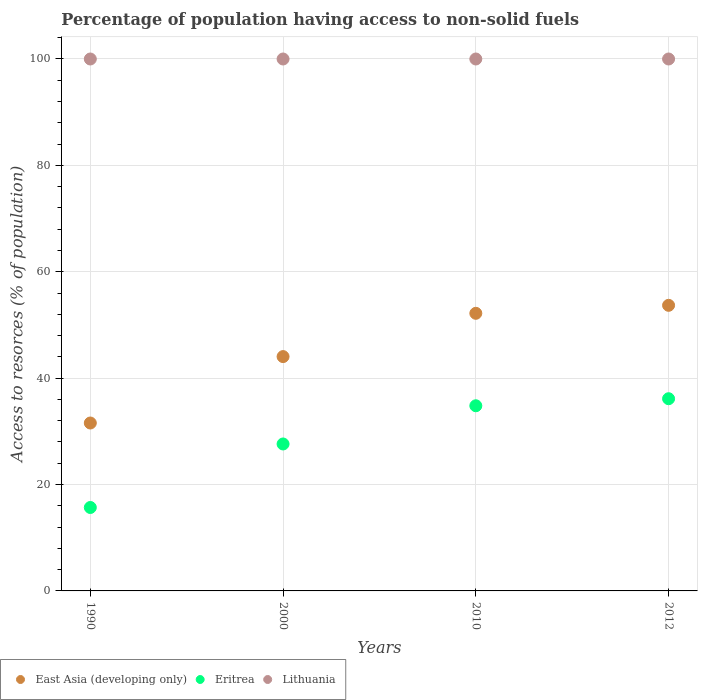How many different coloured dotlines are there?
Offer a terse response. 3. What is the percentage of population having access to non-solid fuels in East Asia (developing only) in 2010?
Keep it short and to the point. 52.19. Across all years, what is the maximum percentage of population having access to non-solid fuels in East Asia (developing only)?
Your answer should be compact. 53.69. Across all years, what is the minimum percentage of population having access to non-solid fuels in Eritrea?
Offer a terse response. 15.68. In which year was the percentage of population having access to non-solid fuels in East Asia (developing only) maximum?
Provide a succinct answer. 2012. In which year was the percentage of population having access to non-solid fuels in Eritrea minimum?
Give a very brief answer. 1990. What is the total percentage of population having access to non-solid fuels in East Asia (developing only) in the graph?
Your response must be concise. 181.5. What is the difference between the percentage of population having access to non-solid fuels in Eritrea in 2000 and that in 2010?
Offer a terse response. -7.18. What is the difference between the percentage of population having access to non-solid fuels in Lithuania in 2000 and the percentage of population having access to non-solid fuels in Eritrea in 2012?
Your answer should be very brief. 63.87. What is the average percentage of population having access to non-solid fuels in Eritrea per year?
Give a very brief answer. 28.56. In the year 2000, what is the difference between the percentage of population having access to non-solid fuels in Eritrea and percentage of population having access to non-solid fuels in East Asia (developing only)?
Your answer should be compact. -16.43. What is the ratio of the percentage of population having access to non-solid fuels in Eritrea in 1990 to that in 2010?
Your answer should be compact. 0.45. Is the difference between the percentage of population having access to non-solid fuels in Eritrea in 1990 and 2000 greater than the difference between the percentage of population having access to non-solid fuels in East Asia (developing only) in 1990 and 2000?
Your answer should be compact. Yes. What is the difference between the highest and the lowest percentage of population having access to non-solid fuels in East Asia (developing only)?
Ensure brevity in your answer.  22.12. In how many years, is the percentage of population having access to non-solid fuels in Eritrea greater than the average percentage of population having access to non-solid fuels in Eritrea taken over all years?
Your response must be concise. 2. Does the percentage of population having access to non-solid fuels in Eritrea monotonically increase over the years?
Offer a terse response. Yes. Is the percentage of population having access to non-solid fuels in East Asia (developing only) strictly greater than the percentage of population having access to non-solid fuels in Lithuania over the years?
Your answer should be very brief. No. Is the percentage of population having access to non-solid fuels in East Asia (developing only) strictly less than the percentage of population having access to non-solid fuels in Eritrea over the years?
Give a very brief answer. No. How many dotlines are there?
Provide a short and direct response. 3. Does the graph contain grids?
Give a very brief answer. Yes. Where does the legend appear in the graph?
Offer a very short reply. Bottom left. How many legend labels are there?
Your response must be concise. 3. How are the legend labels stacked?
Offer a very short reply. Horizontal. What is the title of the graph?
Give a very brief answer. Percentage of population having access to non-solid fuels. Does "Grenada" appear as one of the legend labels in the graph?
Ensure brevity in your answer.  No. What is the label or title of the X-axis?
Your answer should be very brief. Years. What is the label or title of the Y-axis?
Your answer should be very brief. Access to resorces (% of population). What is the Access to resorces (% of population) in East Asia (developing only) in 1990?
Your answer should be very brief. 31.57. What is the Access to resorces (% of population) of Eritrea in 1990?
Your response must be concise. 15.68. What is the Access to resorces (% of population) in Lithuania in 1990?
Provide a succinct answer. 100. What is the Access to resorces (% of population) of East Asia (developing only) in 2000?
Ensure brevity in your answer.  44.05. What is the Access to resorces (% of population) in Eritrea in 2000?
Offer a terse response. 27.62. What is the Access to resorces (% of population) in Lithuania in 2000?
Your response must be concise. 100. What is the Access to resorces (% of population) in East Asia (developing only) in 2010?
Offer a terse response. 52.19. What is the Access to resorces (% of population) of Eritrea in 2010?
Keep it short and to the point. 34.81. What is the Access to resorces (% of population) in East Asia (developing only) in 2012?
Your answer should be compact. 53.69. What is the Access to resorces (% of population) in Eritrea in 2012?
Your response must be concise. 36.13. What is the Access to resorces (% of population) in Lithuania in 2012?
Provide a succinct answer. 100. Across all years, what is the maximum Access to resorces (% of population) in East Asia (developing only)?
Keep it short and to the point. 53.69. Across all years, what is the maximum Access to resorces (% of population) in Eritrea?
Provide a succinct answer. 36.13. Across all years, what is the maximum Access to resorces (% of population) in Lithuania?
Ensure brevity in your answer.  100. Across all years, what is the minimum Access to resorces (% of population) in East Asia (developing only)?
Offer a terse response. 31.57. Across all years, what is the minimum Access to resorces (% of population) in Eritrea?
Your answer should be very brief. 15.68. What is the total Access to resorces (% of population) of East Asia (developing only) in the graph?
Make the answer very short. 181.5. What is the total Access to resorces (% of population) of Eritrea in the graph?
Your answer should be very brief. 114.25. What is the difference between the Access to resorces (% of population) of East Asia (developing only) in 1990 and that in 2000?
Your answer should be very brief. -12.49. What is the difference between the Access to resorces (% of population) of Eritrea in 1990 and that in 2000?
Offer a very short reply. -11.94. What is the difference between the Access to resorces (% of population) of Lithuania in 1990 and that in 2000?
Provide a succinct answer. 0. What is the difference between the Access to resorces (% of population) of East Asia (developing only) in 1990 and that in 2010?
Your answer should be very brief. -20.62. What is the difference between the Access to resorces (% of population) in Eritrea in 1990 and that in 2010?
Offer a terse response. -19.12. What is the difference between the Access to resorces (% of population) of East Asia (developing only) in 1990 and that in 2012?
Your answer should be very brief. -22.12. What is the difference between the Access to resorces (% of population) of Eritrea in 1990 and that in 2012?
Keep it short and to the point. -20.45. What is the difference between the Access to resorces (% of population) in Lithuania in 1990 and that in 2012?
Your answer should be very brief. 0. What is the difference between the Access to resorces (% of population) in East Asia (developing only) in 2000 and that in 2010?
Your response must be concise. -8.14. What is the difference between the Access to resorces (% of population) of Eritrea in 2000 and that in 2010?
Provide a short and direct response. -7.18. What is the difference between the Access to resorces (% of population) of East Asia (developing only) in 2000 and that in 2012?
Keep it short and to the point. -9.64. What is the difference between the Access to resorces (% of population) of Eritrea in 2000 and that in 2012?
Offer a very short reply. -8.51. What is the difference between the Access to resorces (% of population) of East Asia (developing only) in 2010 and that in 2012?
Offer a terse response. -1.5. What is the difference between the Access to resorces (% of population) in Eritrea in 2010 and that in 2012?
Offer a very short reply. -1.32. What is the difference between the Access to resorces (% of population) in East Asia (developing only) in 1990 and the Access to resorces (% of population) in Eritrea in 2000?
Make the answer very short. 3.94. What is the difference between the Access to resorces (% of population) in East Asia (developing only) in 1990 and the Access to resorces (% of population) in Lithuania in 2000?
Keep it short and to the point. -68.43. What is the difference between the Access to resorces (% of population) in Eritrea in 1990 and the Access to resorces (% of population) in Lithuania in 2000?
Your answer should be compact. -84.32. What is the difference between the Access to resorces (% of population) in East Asia (developing only) in 1990 and the Access to resorces (% of population) in Eritrea in 2010?
Make the answer very short. -3.24. What is the difference between the Access to resorces (% of population) of East Asia (developing only) in 1990 and the Access to resorces (% of population) of Lithuania in 2010?
Ensure brevity in your answer.  -68.43. What is the difference between the Access to resorces (% of population) of Eritrea in 1990 and the Access to resorces (% of population) of Lithuania in 2010?
Make the answer very short. -84.32. What is the difference between the Access to resorces (% of population) of East Asia (developing only) in 1990 and the Access to resorces (% of population) of Eritrea in 2012?
Your response must be concise. -4.57. What is the difference between the Access to resorces (% of population) in East Asia (developing only) in 1990 and the Access to resorces (% of population) in Lithuania in 2012?
Ensure brevity in your answer.  -68.43. What is the difference between the Access to resorces (% of population) in Eritrea in 1990 and the Access to resorces (% of population) in Lithuania in 2012?
Ensure brevity in your answer.  -84.32. What is the difference between the Access to resorces (% of population) in East Asia (developing only) in 2000 and the Access to resorces (% of population) in Eritrea in 2010?
Your answer should be very brief. 9.24. What is the difference between the Access to resorces (% of population) in East Asia (developing only) in 2000 and the Access to resorces (% of population) in Lithuania in 2010?
Provide a short and direct response. -55.95. What is the difference between the Access to resorces (% of population) in Eritrea in 2000 and the Access to resorces (% of population) in Lithuania in 2010?
Keep it short and to the point. -72.38. What is the difference between the Access to resorces (% of population) of East Asia (developing only) in 2000 and the Access to resorces (% of population) of Eritrea in 2012?
Offer a very short reply. 7.92. What is the difference between the Access to resorces (% of population) in East Asia (developing only) in 2000 and the Access to resorces (% of population) in Lithuania in 2012?
Ensure brevity in your answer.  -55.95. What is the difference between the Access to resorces (% of population) of Eritrea in 2000 and the Access to resorces (% of population) of Lithuania in 2012?
Your response must be concise. -72.38. What is the difference between the Access to resorces (% of population) of East Asia (developing only) in 2010 and the Access to resorces (% of population) of Eritrea in 2012?
Ensure brevity in your answer.  16.06. What is the difference between the Access to resorces (% of population) in East Asia (developing only) in 2010 and the Access to resorces (% of population) in Lithuania in 2012?
Provide a short and direct response. -47.81. What is the difference between the Access to resorces (% of population) of Eritrea in 2010 and the Access to resorces (% of population) of Lithuania in 2012?
Keep it short and to the point. -65.19. What is the average Access to resorces (% of population) of East Asia (developing only) per year?
Make the answer very short. 45.38. What is the average Access to resorces (% of population) in Eritrea per year?
Your answer should be compact. 28.56. What is the average Access to resorces (% of population) in Lithuania per year?
Offer a terse response. 100. In the year 1990, what is the difference between the Access to resorces (% of population) of East Asia (developing only) and Access to resorces (% of population) of Eritrea?
Offer a terse response. 15.88. In the year 1990, what is the difference between the Access to resorces (% of population) of East Asia (developing only) and Access to resorces (% of population) of Lithuania?
Ensure brevity in your answer.  -68.43. In the year 1990, what is the difference between the Access to resorces (% of population) of Eritrea and Access to resorces (% of population) of Lithuania?
Provide a succinct answer. -84.32. In the year 2000, what is the difference between the Access to resorces (% of population) of East Asia (developing only) and Access to resorces (% of population) of Eritrea?
Make the answer very short. 16.43. In the year 2000, what is the difference between the Access to resorces (% of population) in East Asia (developing only) and Access to resorces (% of population) in Lithuania?
Keep it short and to the point. -55.95. In the year 2000, what is the difference between the Access to resorces (% of population) in Eritrea and Access to resorces (% of population) in Lithuania?
Offer a terse response. -72.38. In the year 2010, what is the difference between the Access to resorces (% of population) in East Asia (developing only) and Access to resorces (% of population) in Eritrea?
Provide a succinct answer. 17.38. In the year 2010, what is the difference between the Access to resorces (% of population) of East Asia (developing only) and Access to resorces (% of population) of Lithuania?
Keep it short and to the point. -47.81. In the year 2010, what is the difference between the Access to resorces (% of population) of Eritrea and Access to resorces (% of population) of Lithuania?
Offer a very short reply. -65.19. In the year 2012, what is the difference between the Access to resorces (% of population) of East Asia (developing only) and Access to resorces (% of population) of Eritrea?
Ensure brevity in your answer.  17.56. In the year 2012, what is the difference between the Access to resorces (% of population) in East Asia (developing only) and Access to resorces (% of population) in Lithuania?
Your response must be concise. -46.31. In the year 2012, what is the difference between the Access to resorces (% of population) in Eritrea and Access to resorces (% of population) in Lithuania?
Keep it short and to the point. -63.87. What is the ratio of the Access to resorces (% of population) of East Asia (developing only) in 1990 to that in 2000?
Provide a succinct answer. 0.72. What is the ratio of the Access to resorces (% of population) of Eritrea in 1990 to that in 2000?
Your answer should be compact. 0.57. What is the ratio of the Access to resorces (% of population) in East Asia (developing only) in 1990 to that in 2010?
Your answer should be very brief. 0.6. What is the ratio of the Access to resorces (% of population) of Eritrea in 1990 to that in 2010?
Your response must be concise. 0.45. What is the ratio of the Access to resorces (% of population) in Lithuania in 1990 to that in 2010?
Your answer should be very brief. 1. What is the ratio of the Access to resorces (% of population) of East Asia (developing only) in 1990 to that in 2012?
Keep it short and to the point. 0.59. What is the ratio of the Access to resorces (% of population) in Eritrea in 1990 to that in 2012?
Your response must be concise. 0.43. What is the ratio of the Access to resorces (% of population) in East Asia (developing only) in 2000 to that in 2010?
Offer a terse response. 0.84. What is the ratio of the Access to resorces (% of population) in Eritrea in 2000 to that in 2010?
Keep it short and to the point. 0.79. What is the ratio of the Access to resorces (% of population) of East Asia (developing only) in 2000 to that in 2012?
Offer a terse response. 0.82. What is the ratio of the Access to resorces (% of population) of Eritrea in 2000 to that in 2012?
Your answer should be compact. 0.76. What is the ratio of the Access to resorces (% of population) in Lithuania in 2000 to that in 2012?
Ensure brevity in your answer.  1. What is the ratio of the Access to resorces (% of population) in East Asia (developing only) in 2010 to that in 2012?
Your answer should be compact. 0.97. What is the ratio of the Access to resorces (% of population) in Eritrea in 2010 to that in 2012?
Keep it short and to the point. 0.96. What is the ratio of the Access to resorces (% of population) in Lithuania in 2010 to that in 2012?
Your answer should be compact. 1. What is the difference between the highest and the second highest Access to resorces (% of population) in East Asia (developing only)?
Your response must be concise. 1.5. What is the difference between the highest and the second highest Access to resorces (% of population) of Eritrea?
Provide a succinct answer. 1.32. What is the difference between the highest and the lowest Access to resorces (% of population) of East Asia (developing only)?
Offer a very short reply. 22.12. What is the difference between the highest and the lowest Access to resorces (% of population) in Eritrea?
Make the answer very short. 20.45. What is the difference between the highest and the lowest Access to resorces (% of population) of Lithuania?
Provide a short and direct response. 0. 